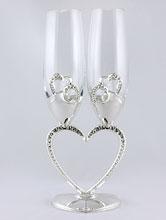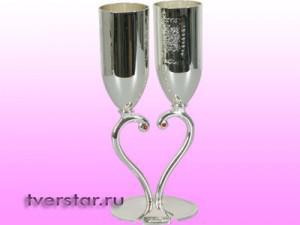The first image is the image on the left, the second image is the image on the right. Assess this claim about the two images: "There are four clear glasses with silver stems.". Correct or not? Answer yes or no. No. 